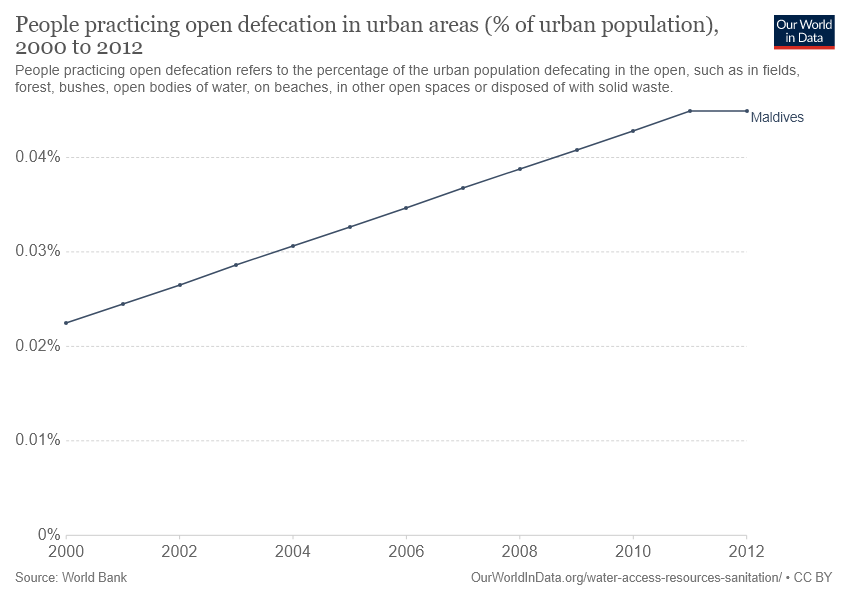Identify some key points in this picture. The number of urban population peaked in [2011, 2012] in [country/region]. 